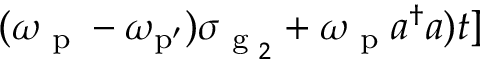Convert formula to latex. <formula><loc_0><loc_0><loc_500><loc_500>( \omega _ { p } - \omega _ { { p ^ { \prime } } } ) \sigma _ { g _ { 2 } } + \omega _ { p } a ^ { \dagger } a ) t ]</formula> 